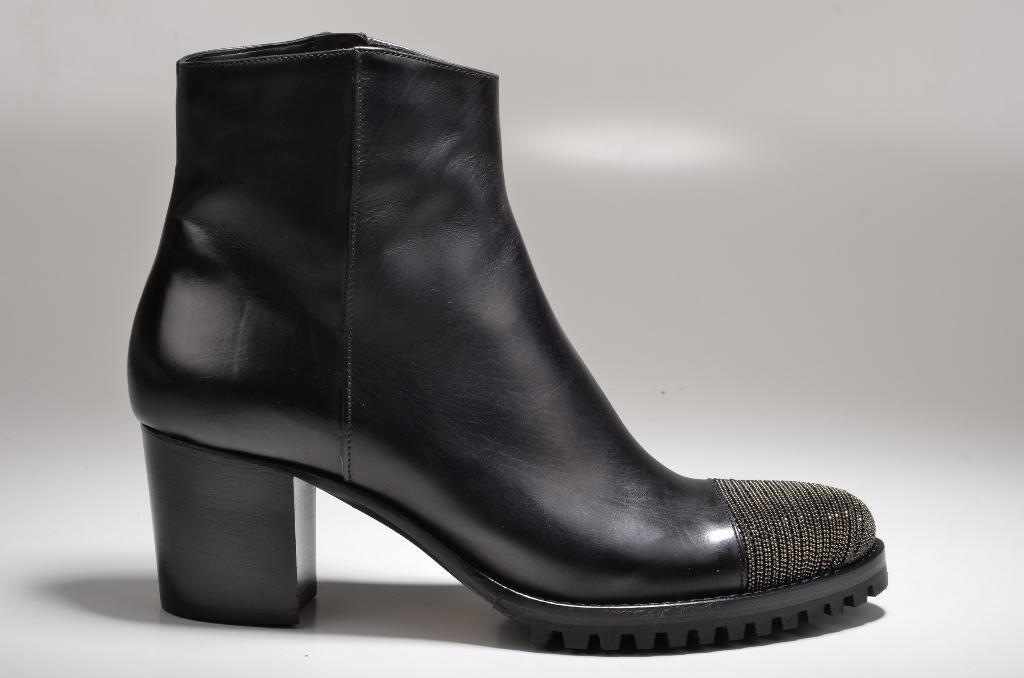How would you summarize this image in a sentence or two? In this image I can see a black colour shoe in the front and I can also see white colour in the background. 